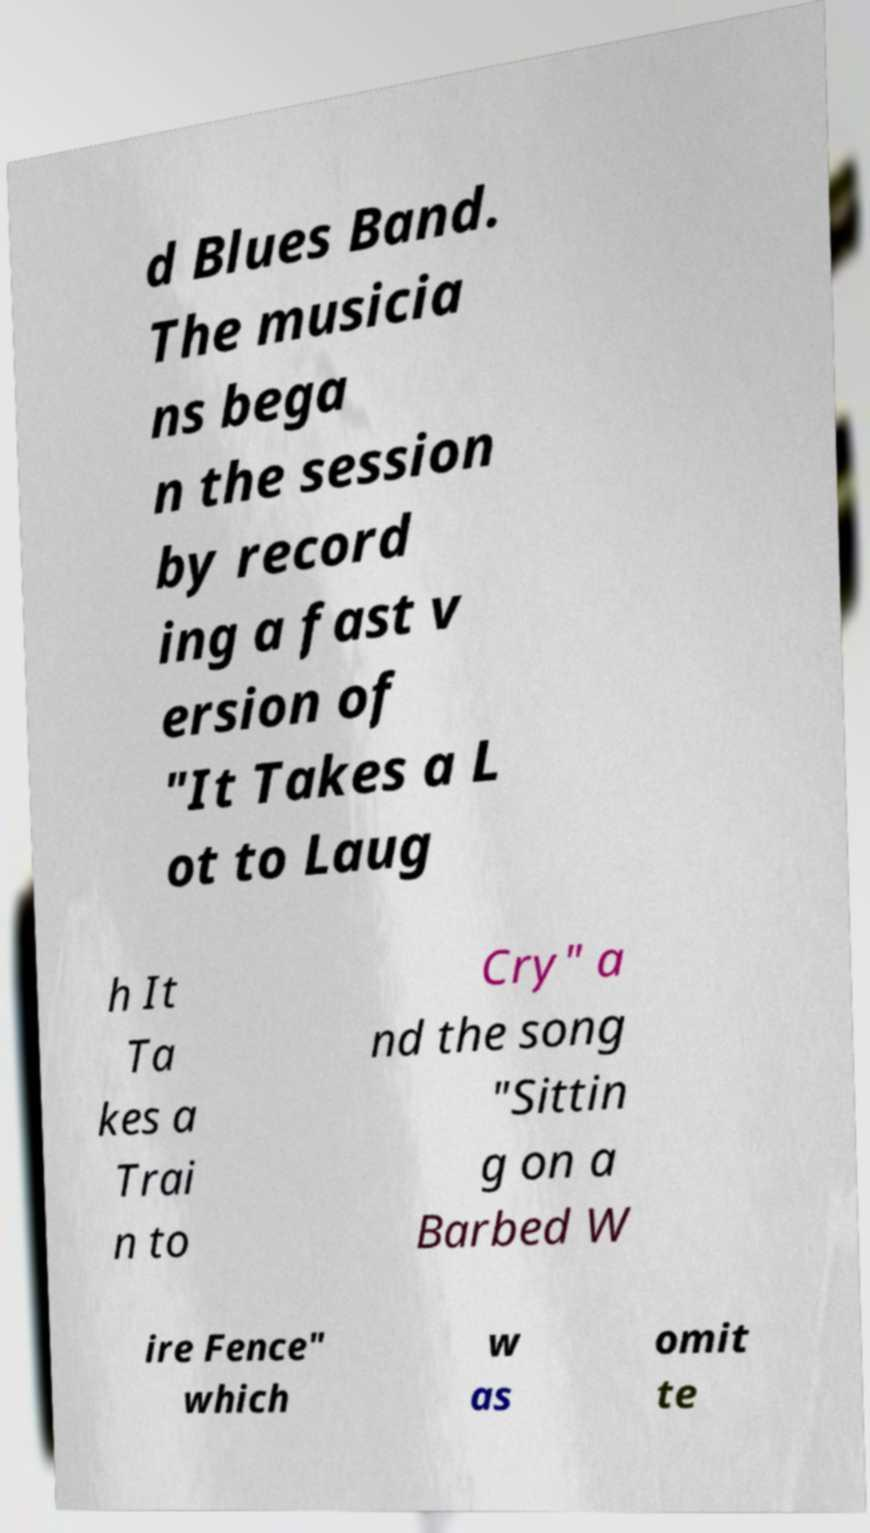Please read and relay the text visible in this image. What does it say? d Blues Band. The musicia ns bega n the session by record ing a fast v ersion of "It Takes a L ot to Laug h It Ta kes a Trai n to Cry" a nd the song "Sittin g on a Barbed W ire Fence" which w as omit te 